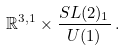<formula> <loc_0><loc_0><loc_500><loc_500>\mathbb { R } ^ { 3 , 1 } \times \frac { S L ( 2 ) _ { 1 } } { U ( 1 ) } \, .</formula> 